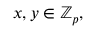Convert formula to latex. <formula><loc_0><loc_0><loc_500><loc_500>x , y \in \mathbb { Z } _ { p } ,</formula> 